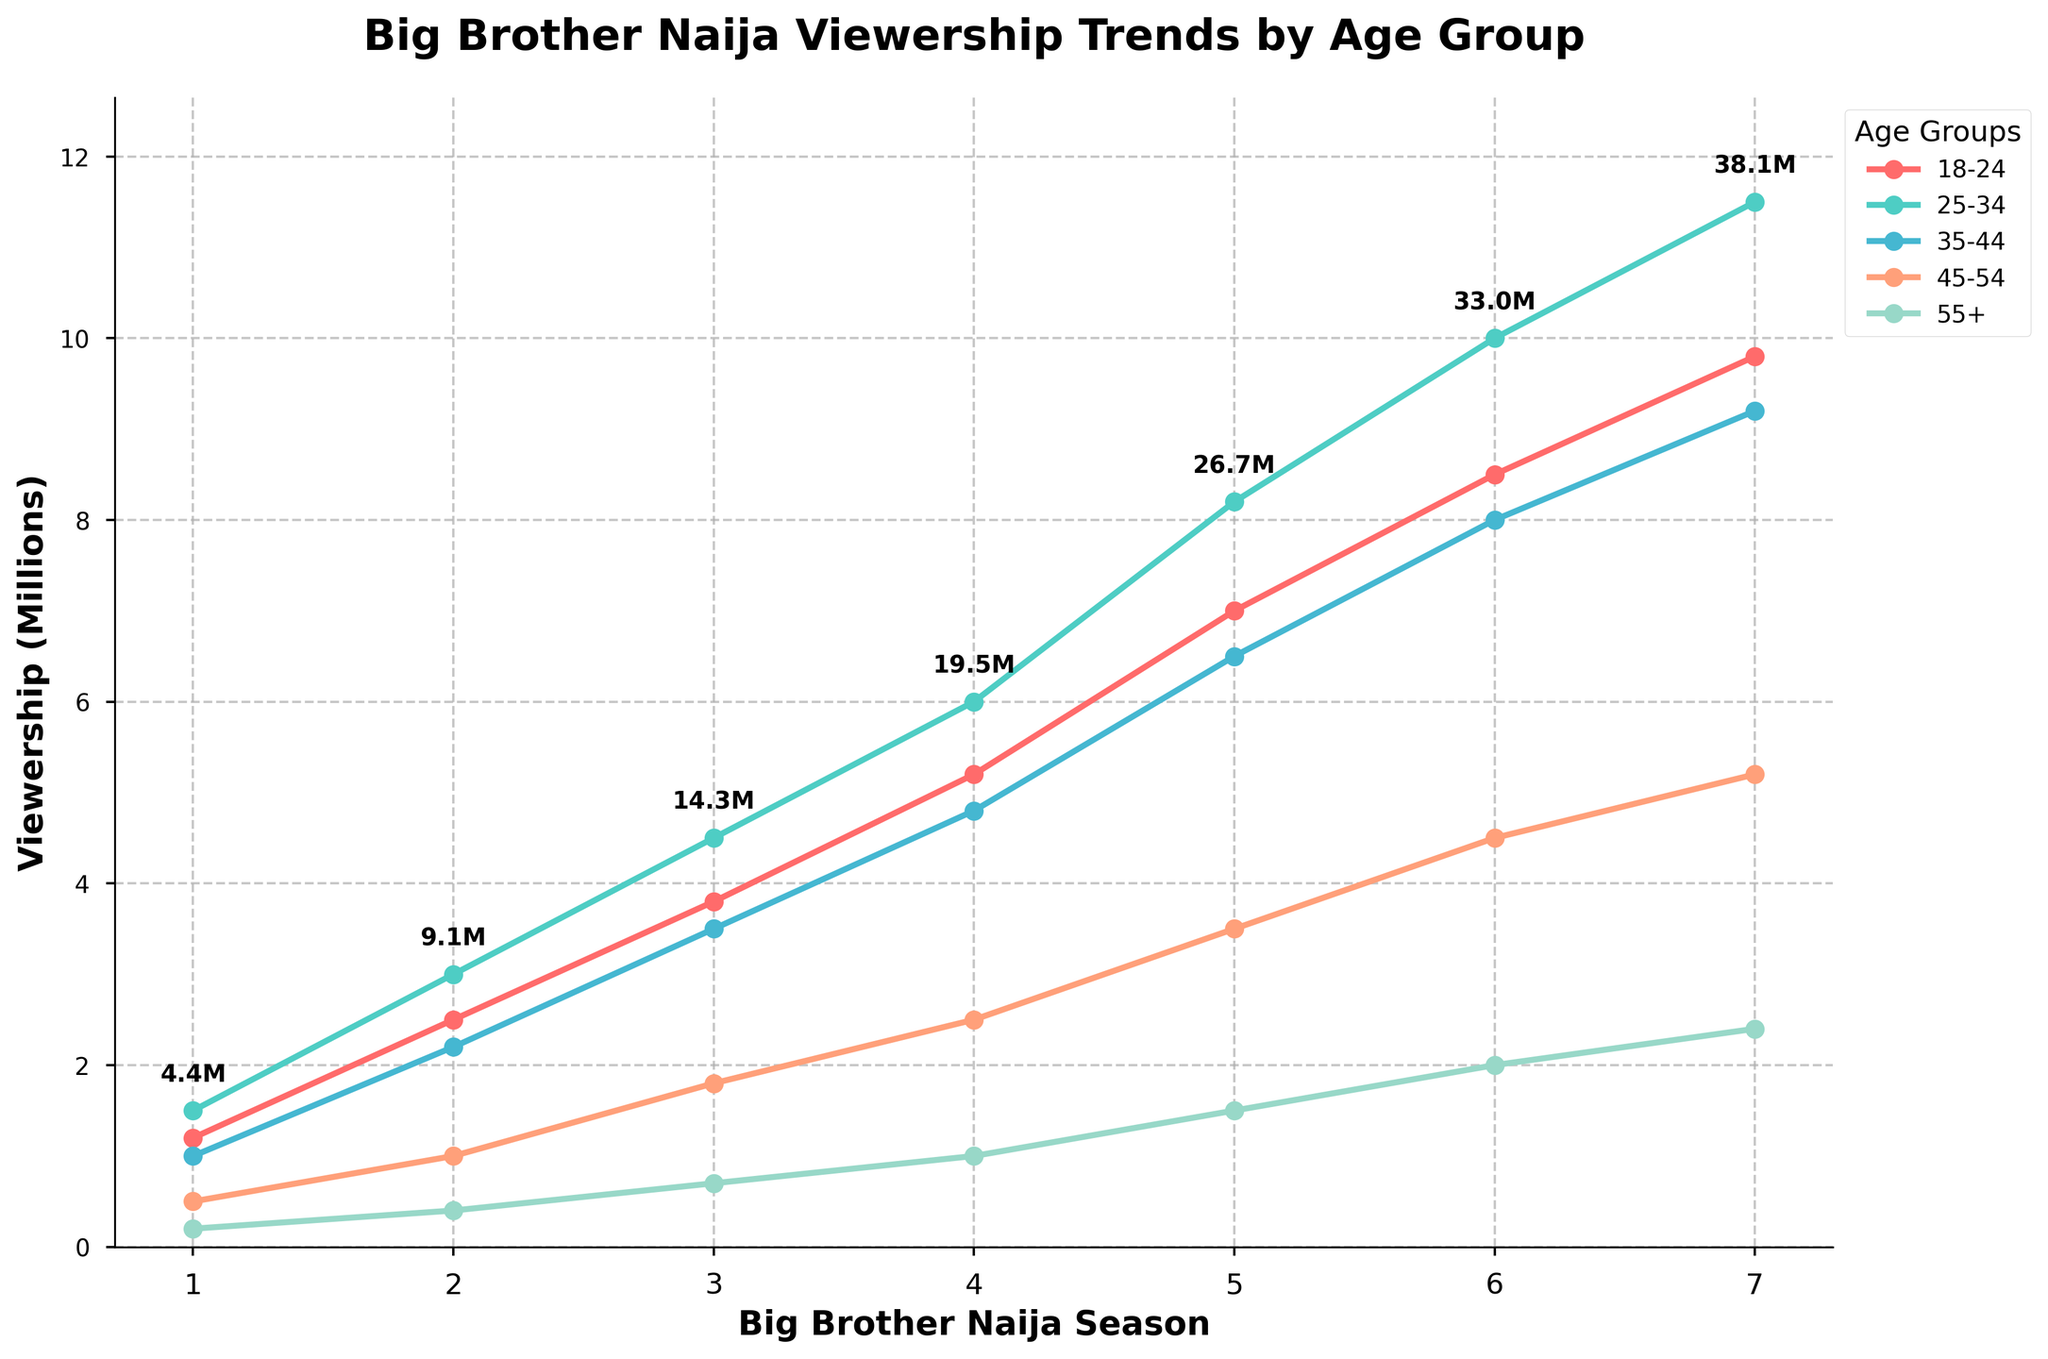Which age group saw the highest increase in viewership from Season 1 (2006) to Season 7 (2022)? The viewership for each age group in Season 1 (2006) and Season 7 (2022) is provided. By subtracting the values of Season 1 from Season 7 for each age group, we find the differences: 
- 18-24: 9.8 - 1.2 = 8.6
- 25-34: 11.5 - 1.5 = 10.0
- 35-44: 9.2 - 1.0 = 8.2
- 45-54: 5.2 - 0.5 = 4.7
- 55+: 2.4 - 0.2 = 2.2 
The highest increase in viewership is for the 25-34 age group, which saw an increase of 10.0 million viewers.
Answer: 25-34 Which Season had the highest total viewership across all age groups? For each season, calculate the total viewership by summing the numbers across all age groups:
- Season 1: 1.2 + 1.5 + 1.0 + 0.5 + 0.2 = 4.4M
- Season 2: 2.5 + 3.0 + 2.2 + 1.0 + 0.4 = 9.1M
- Season 3: 3.8 + 4.5 + 3.5 + 1.8 + 0.7 = 14.3M 
- Season 4: 5.2 + 6.0 + 4.8 + 2.5 + 1.0 = 19.5M 
- Season 5: 7.0 + 8.2 + 6.5 + 3.5 + 1.5 = 26.7M 
- Season 6: 8.5 + 10.0 + 8.0 + 4.5 + 2.0 = 33.0M 
- Season 7: 9.8 + 11.5 + 9.2 + 5.2 + 2.4 = 38.1M
The highest total viewership is in Season 7 with 38.1 million viewers.
Answer: Season 7 (2022) Between which two adjacent seasons did the 18-24 age group see the largest jump in viewership? Compare the differences in viewership for the 18-24 age group between consecutive seasons:
- Season 1 to Season 2: 2.5 - 1.2 = 1.3M
- Season 2 to Season 3: 3.8 - 2.5 = 1.3M
- Season 3 to Season 4: 5.2 - 3.8 = 1.4M
- Season 4 to Season 5: 7.0 - 5.2 = 1.8M
- Season 5 to Season 6: 8.5 - 7.0 = 1.5M
- Season 6 to Season 7: 9.8 - 8.5 = 1.3M
The largest jump is between Season 4 and Season 5 with an increase of 1.8 million viewers.
Answer: Season 4 (2019) to Season 5 (2020) What is the trend in viewership for the 55+ age group from Season 1 to Season 7? The viewership data for the 55+ age group across all seasons are:
- Season 1: 0.2M
- Season 2: 0.4M
- Season 3: 0.7M
- Season 4: 1.0M
- Season 5: 1.5M
- Season 6: 2.0M
- Season 7: 2.4M
The trend shows a continuous increase in viewership for the 55+ age group across all seasons.
Answer: Continuous increase What is the total increase in viewership from Season 1 to Season 7 for all age groups combined? To find the total increase, subtract the total viewership of Season 1 from that of Season 7:
- Total for Season 1: 4.4M
- Total for Season 7: 38.1M
- Increase: 38.1 - 4.4 = 33.7M
The total increase in viewership from Season 1 to Season 7 is 33.7 million.
Answer: 33.7M Which season has the smallest viewership for the 25-34 age group? By comparing the viewership numbers for the 25-34 age group across all seasons:
- Season 1: 1.5M
- Season 2: 3.0M
- Season 3: 4.5M
- Season 4: 6.0M
- Season 5: 8.2M
- Season 6: 10.0M
- Season 7: 11.5M
The smallest viewership for the 25-34 age group is in Season 1 with 1.5 million viewers.
Answer: Season 1 (2006) What's the cumulative viewership for the 35-44 age group across all seasons? Add up the viewership numbers for the 35-44 age group across all seasons:
- Season 1: 1.0M
- Season 2: 2.2M
- Season 3: 3.5M
- Season 4: 4.8M
- Season 5: 6.5M
- Season 6: 8.0M
- Season 7: 9.2M
The cumulative viewership is 1.0 + 2.2 + 3.5 + 4.8 + 6.5 + 8.0 + 9.2 = 35.2 million viewers.
Answer: 35.2M 